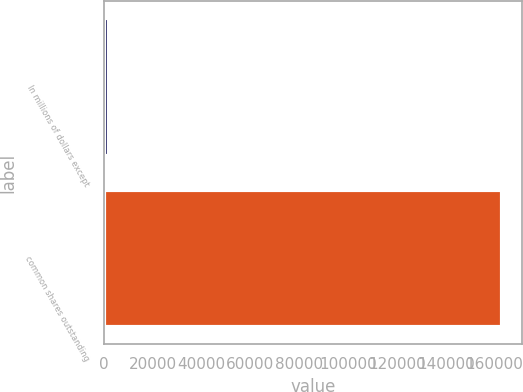<chart> <loc_0><loc_0><loc_500><loc_500><bar_chart><fcel>In millions of dollars except<fcel>common shares outstanding<nl><fcel>2010<fcel>163156<nl></chart> 